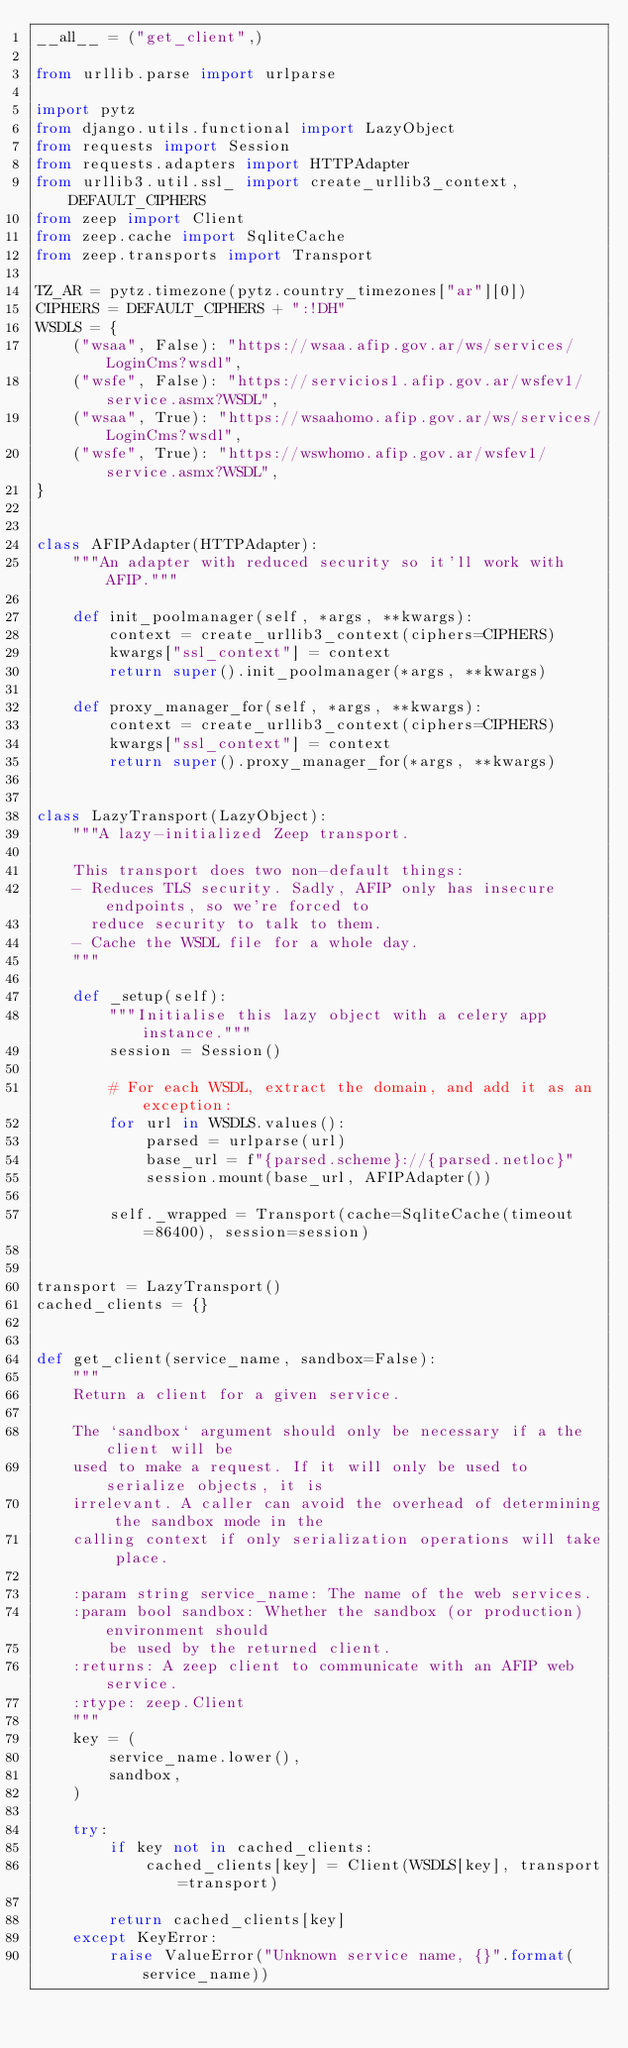Convert code to text. <code><loc_0><loc_0><loc_500><loc_500><_Python_>__all__ = ("get_client",)

from urllib.parse import urlparse

import pytz
from django.utils.functional import LazyObject
from requests import Session
from requests.adapters import HTTPAdapter
from urllib3.util.ssl_ import create_urllib3_context, DEFAULT_CIPHERS
from zeep import Client
from zeep.cache import SqliteCache
from zeep.transports import Transport

TZ_AR = pytz.timezone(pytz.country_timezones["ar"][0])
CIPHERS = DEFAULT_CIPHERS + ":!DH"
WSDLS = {
    ("wsaa", False): "https://wsaa.afip.gov.ar/ws/services/LoginCms?wsdl",
    ("wsfe", False): "https://servicios1.afip.gov.ar/wsfev1/service.asmx?WSDL",
    ("wsaa", True): "https://wsaahomo.afip.gov.ar/ws/services/LoginCms?wsdl",
    ("wsfe", True): "https://wswhomo.afip.gov.ar/wsfev1/service.asmx?WSDL",
}


class AFIPAdapter(HTTPAdapter):
    """An adapter with reduced security so it'll work with AFIP."""

    def init_poolmanager(self, *args, **kwargs):
        context = create_urllib3_context(ciphers=CIPHERS)
        kwargs["ssl_context"] = context
        return super().init_poolmanager(*args, **kwargs)

    def proxy_manager_for(self, *args, **kwargs):
        context = create_urllib3_context(ciphers=CIPHERS)
        kwargs["ssl_context"] = context
        return super().proxy_manager_for(*args, **kwargs)


class LazyTransport(LazyObject):
    """A lazy-initialized Zeep transport.

    This transport does two non-default things:
    - Reduces TLS security. Sadly, AFIP only has insecure endpoints, so we're forced to
      reduce security to talk to them.
    - Cache the WSDL file for a whole day.
    """

    def _setup(self):
        """Initialise this lazy object with a celery app instance."""
        session = Session()

        # For each WSDL, extract the domain, and add it as an exception:
        for url in WSDLS.values():
            parsed = urlparse(url)
            base_url = f"{parsed.scheme}://{parsed.netloc}"
            session.mount(base_url, AFIPAdapter())

        self._wrapped = Transport(cache=SqliteCache(timeout=86400), session=session)


transport = LazyTransport()
cached_clients = {}


def get_client(service_name, sandbox=False):
    """
    Return a client for a given service.

    The `sandbox` argument should only be necessary if a the client will be
    used to make a request. If it will only be used to serialize objects, it is
    irrelevant. A caller can avoid the overhead of determining the sandbox mode in the
    calling context if only serialization operations will take place.

    :param string service_name: The name of the web services.
    :param bool sandbox: Whether the sandbox (or production) environment should
        be used by the returned client.
    :returns: A zeep client to communicate with an AFIP web service.
    :rtype: zeep.Client
    """
    key = (
        service_name.lower(),
        sandbox,
    )

    try:
        if key not in cached_clients:
            cached_clients[key] = Client(WSDLS[key], transport=transport)

        return cached_clients[key]
    except KeyError:
        raise ValueError("Unknown service name, {}".format(service_name))
</code> 